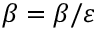Convert formula to latex. <formula><loc_0><loc_0><loc_500><loc_500>\beta = \beta / \varepsilon</formula> 